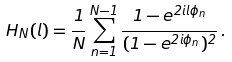Convert formula to latex. <formula><loc_0><loc_0><loc_500><loc_500>H _ { N } ( l ) = \frac { 1 } { N } \sum _ { n = 1 } ^ { N - 1 } \frac { 1 - e ^ { 2 i l \phi _ { n } } } { ( 1 - e ^ { 2 i \phi _ { n } } ) ^ { 2 } } \, .</formula> 